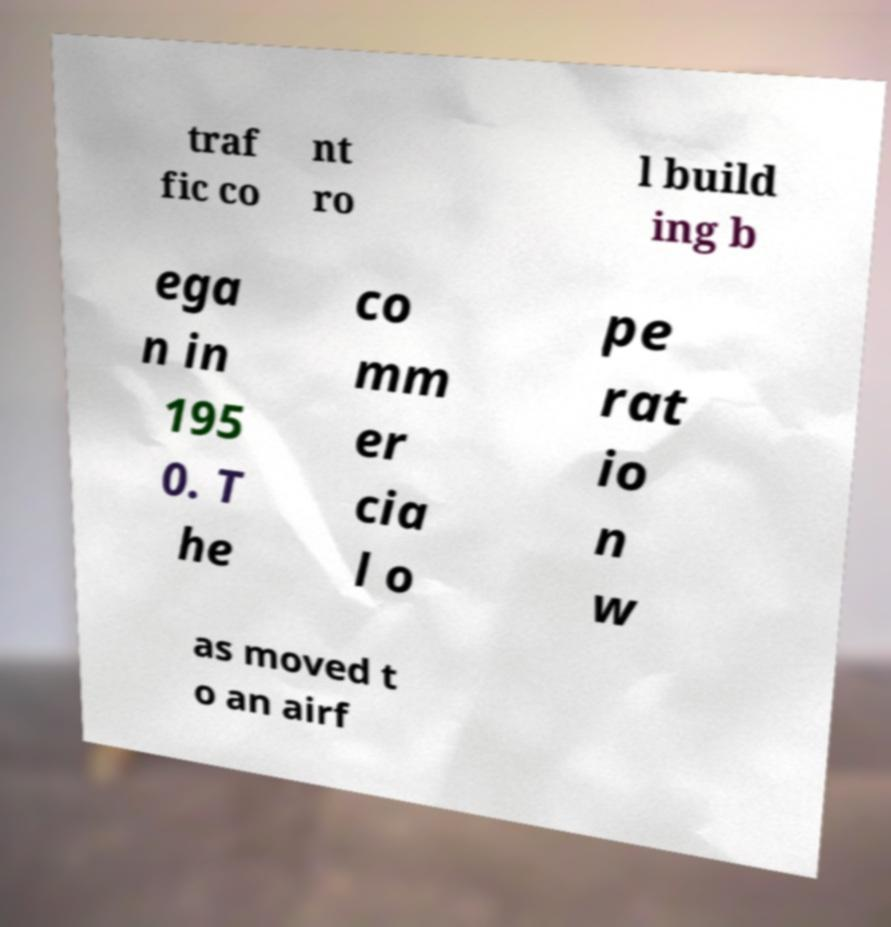Please read and relay the text visible in this image. What does it say? traf fic co nt ro l build ing b ega n in 195 0. T he co mm er cia l o pe rat io n w as moved t o an airf 